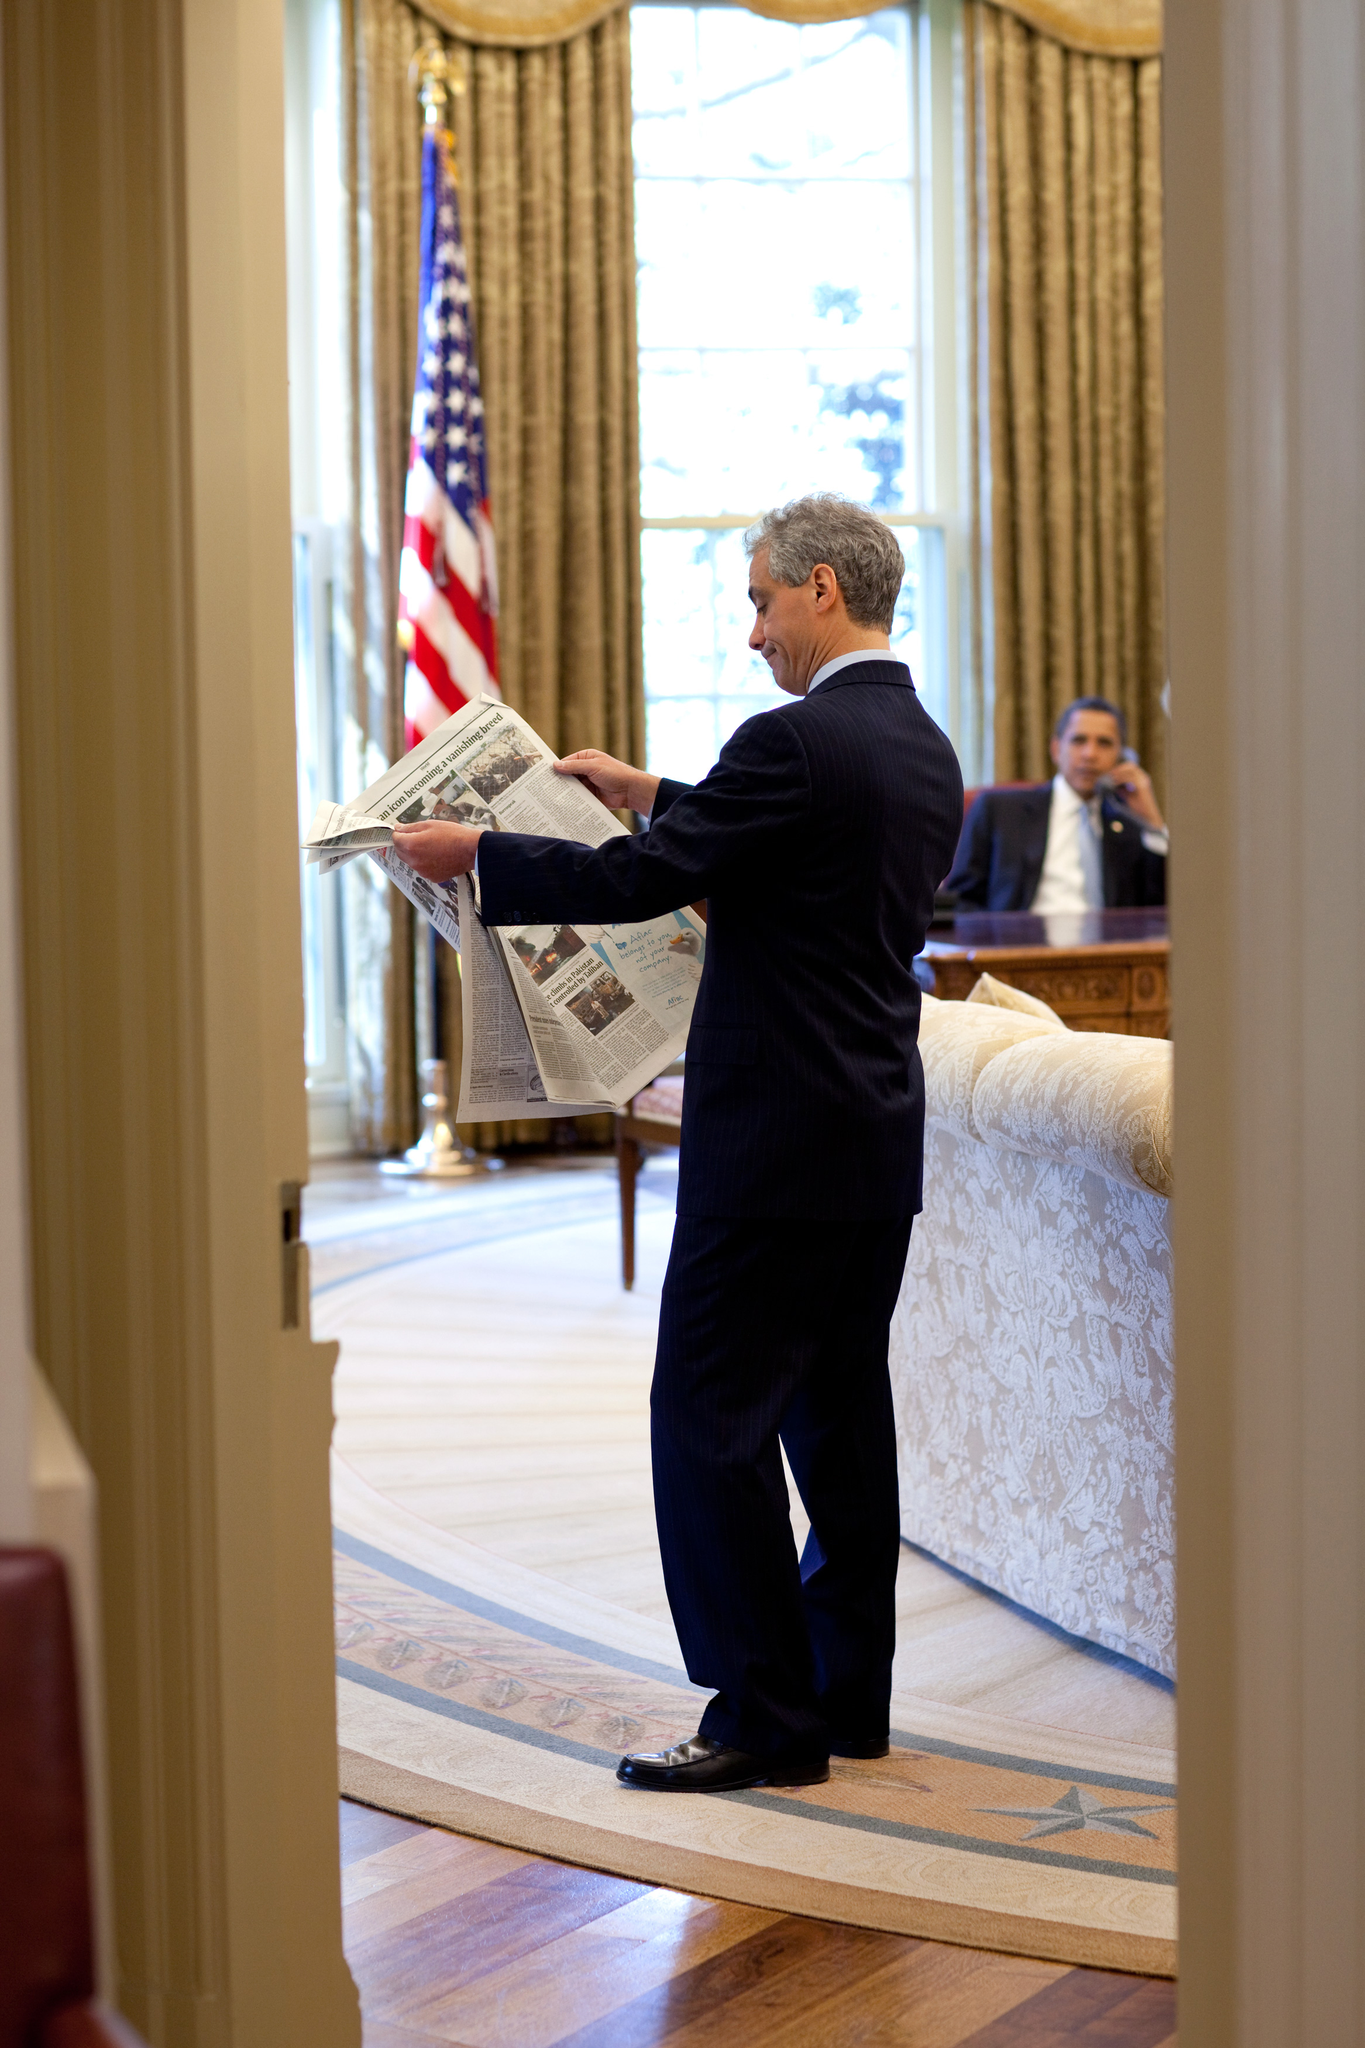What activities might be popular in this area during the time of year depicted in the image? During late spring or early summer, activities like hiking, mountain biking, and photography would be popular in this area. The mild weather and the natural beauty of blooming flowers and lush landscapes provide perfect conditions for outdoor sports and leisure activities. Additionally, the presence of water bodies might attract enthusiasts interested in fishing or canoeing. 